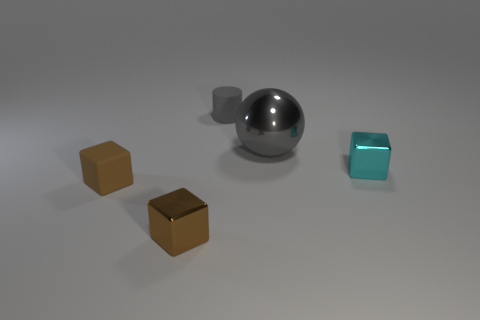Add 1 small rubber things. How many objects exist? 6 Subtract all balls. How many objects are left? 4 Add 2 matte blocks. How many matte blocks are left? 3 Add 3 small cyan matte cylinders. How many small cyan matte cylinders exist? 3 Subtract 0 blue spheres. How many objects are left? 5 Subtract all metallic objects. Subtract all matte cylinders. How many objects are left? 1 